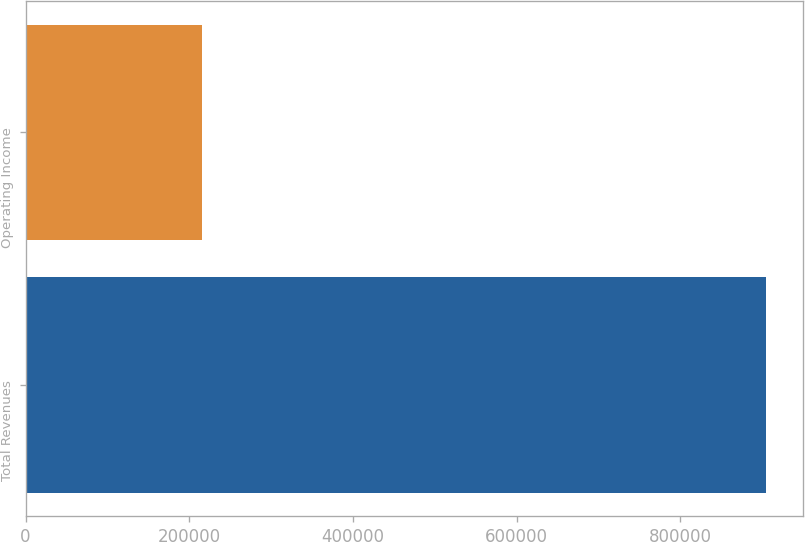Convert chart to OTSL. <chart><loc_0><loc_0><loc_500><loc_500><bar_chart><fcel>Total Revenues<fcel>Operating Income<nl><fcel>905076<fcel>216049<nl></chart> 